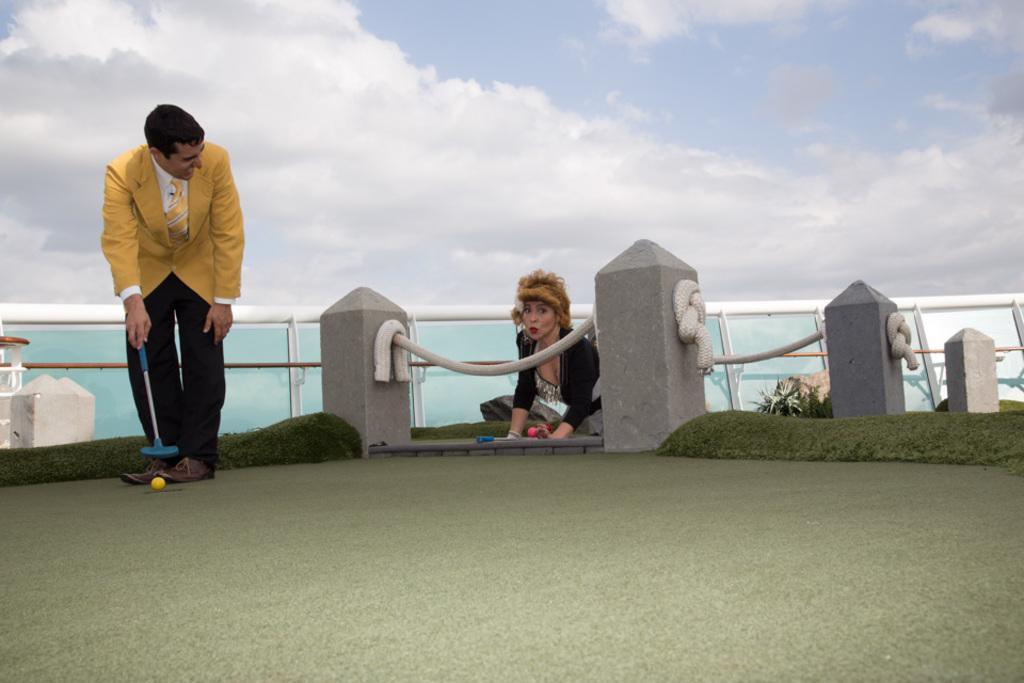Describe this image in one or two sentences. In the image there is a man playing some game and around the man there is a fencing, behind the rope of the fencing there is a woman and behind the woman there are many glasses fit to a pole. 